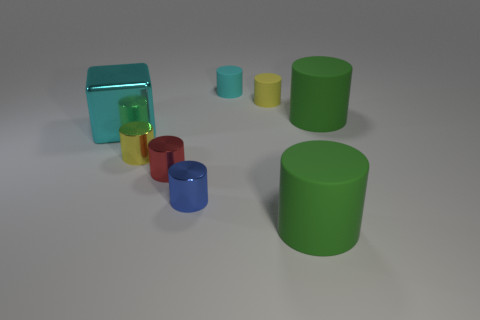There is a big cube; does it have the same color as the big cylinder in front of the big cyan metallic object?
Offer a terse response. No. Is the number of cubes that are right of the small blue object less than the number of large cyan shiny things?
Ensure brevity in your answer.  Yes. What number of other objects are there of the same size as the cyan cylinder?
Your answer should be compact. 4. There is a small thing that is to the right of the small cyan matte cylinder; does it have the same shape as the tiny yellow shiny object?
Provide a short and direct response. Yes. Is the number of red cylinders to the right of the small cyan rubber object greater than the number of brown metallic balls?
Your response must be concise. No. The big thing that is on the right side of the red metallic cylinder and behind the yellow metallic cylinder is made of what material?
Your answer should be very brief. Rubber. Is there anything else that is the same shape as the cyan matte thing?
Offer a very short reply. Yes. How many large green rubber objects are in front of the yellow shiny thing and behind the large cyan object?
Offer a very short reply. 0. What is the material of the small red thing?
Your answer should be compact. Metal. Are there the same number of green matte cylinders that are on the left side of the red object and small cylinders?
Offer a terse response. No. 